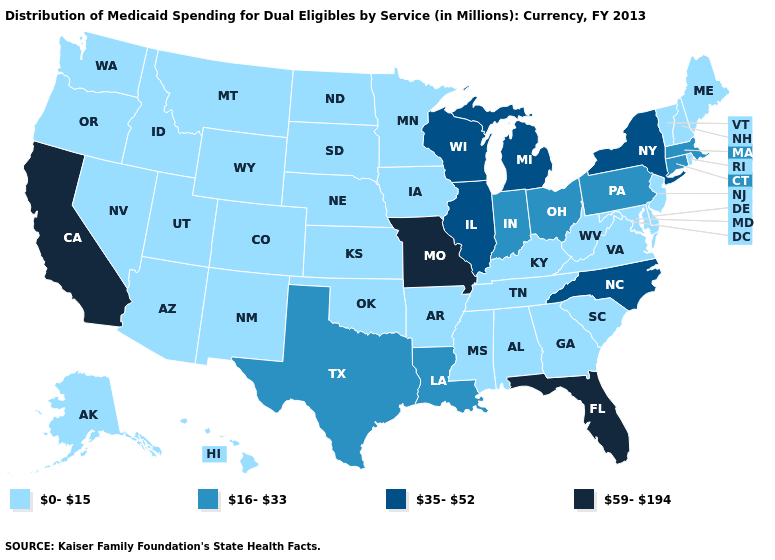What is the highest value in the MidWest ?
Quick response, please. 59-194. Which states have the highest value in the USA?
Quick response, please. California, Florida, Missouri. Which states have the highest value in the USA?
Be succinct. California, Florida, Missouri. What is the lowest value in states that border Oklahoma?
Give a very brief answer. 0-15. What is the value of West Virginia?
Be succinct. 0-15. Does Texas have the lowest value in the South?
Write a very short answer. No. Name the states that have a value in the range 0-15?
Be succinct. Alabama, Alaska, Arizona, Arkansas, Colorado, Delaware, Georgia, Hawaii, Idaho, Iowa, Kansas, Kentucky, Maine, Maryland, Minnesota, Mississippi, Montana, Nebraska, Nevada, New Hampshire, New Jersey, New Mexico, North Dakota, Oklahoma, Oregon, Rhode Island, South Carolina, South Dakota, Tennessee, Utah, Vermont, Virginia, Washington, West Virginia, Wyoming. How many symbols are there in the legend?
Give a very brief answer. 4. Among the states that border West Virginia , does Pennsylvania have the highest value?
Write a very short answer. Yes. Name the states that have a value in the range 59-194?
Answer briefly. California, Florida, Missouri. Name the states that have a value in the range 0-15?
Short answer required. Alabama, Alaska, Arizona, Arkansas, Colorado, Delaware, Georgia, Hawaii, Idaho, Iowa, Kansas, Kentucky, Maine, Maryland, Minnesota, Mississippi, Montana, Nebraska, Nevada, New Hampshire, New Jersey, New Mexico, North Dakota, Oklahoma, Oregon, Rhode Island, South Carolina, South Dakota, Tennessee, Utah, Vermont, Virginia, Washington, West Virginia, Wyoming. Does Arkansas have the same value as Pennsylvania?
Concise answer only. No. Name the states that have a value in the range 0-15?
Give a very brief answer. Alabama, Alaska, Arizona, Arkansas, Colorado, Delaware, Georgia, Hawaii, Idaho, Iowa, Kansas, Kentucky, Maine, Maryland, Minnesota, Mississippi, Montana, Nebraska, Nevada, New Hampshire, New Jersey, New Mexico, North Dakota, Oklahoma, Oregon, Rhode Island, South Carolina, South Dakota, Tennessee, Utah, Vermont, Virginia, Washington, West Virginia, Wyoming. Does the first symbol in the legend represent the smallest category?
Give a very brief answer. Yes. Name the states that have a value in the range 35-52?
Write a very short answer. Illinois, Michigan, New York, North Carolina, Wisconsin. 